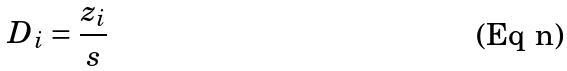Convert formula to latex. <formula><loc_0><loc_0><loc_500><loc_500>D _ { i } = \frac { z _ { i } } { s }</formula> 